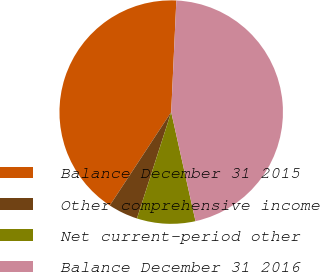Convert chart. <chart><loc_0><loc_0><loc_500><loc_500><pie_chart><fcel>Balance December 31 2015<fcel>Other comprehensive income<fcel>Net current-period other<fcel>Balance December 31 2016<nl><fcel>41.48%<fcel>4.3%<fcel>8.45%<fcel>45.78%<nl></chart> 